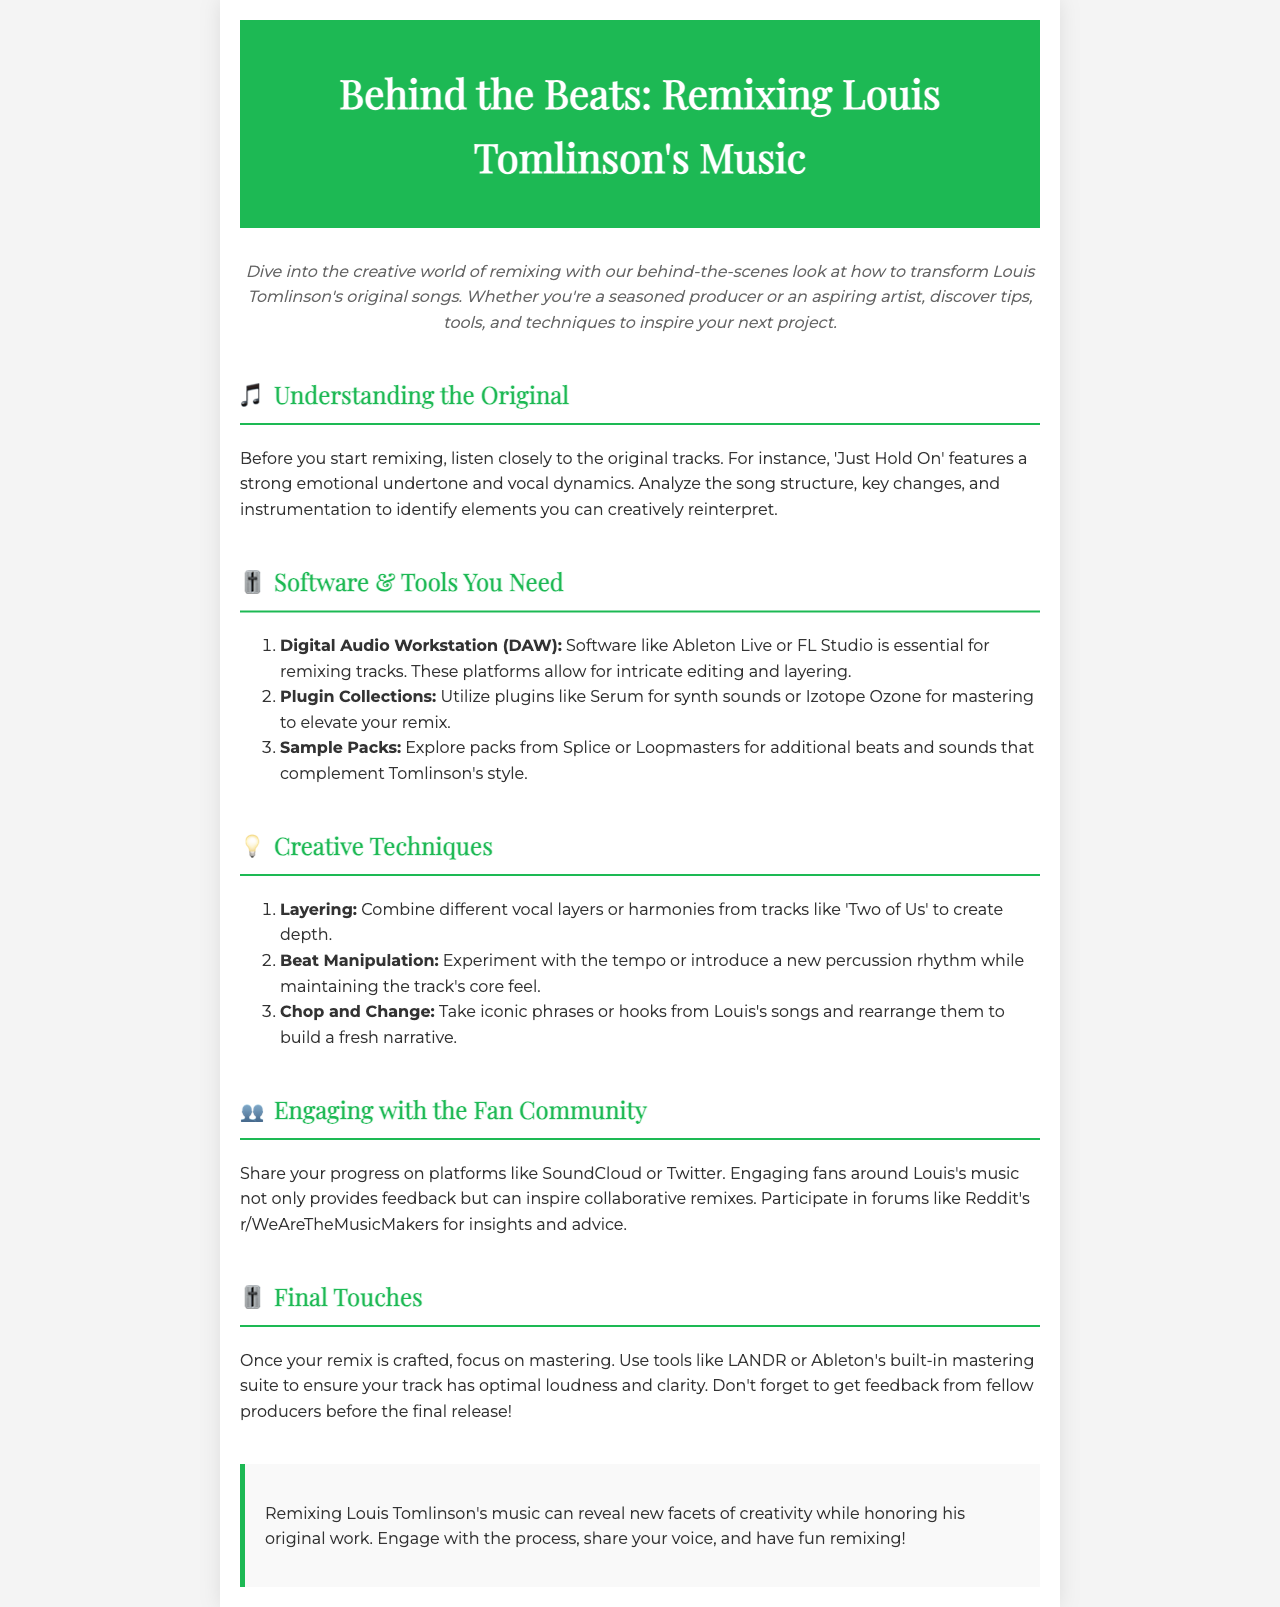what is the title of the newsletter? The title is written in the header of the document and states the main focus of the newsletter.
Answer: Behind the Beats: Remixing Louis Tomlinson's Music what is the first creative technique mentioned? The document lists techniques for remixing, starting with layering as the first technique under Creative Techniques.
Answer: Layering which software is mentioned as essential for remixing? The document specifies a Digital Audio Workstation (DAW) that is crucial for remixing tracks.
Answer: Ableton Live what community platform is recommended for sharing progress? The document suggests a platform where producers can share their work and engage with fans about Louis's music.
Answer: SoundCloud how many types of creative techniques are listed in the document? The document enumerates the different creative techniques for remixing, providing a clear count of the items listed.
Answer: Three 